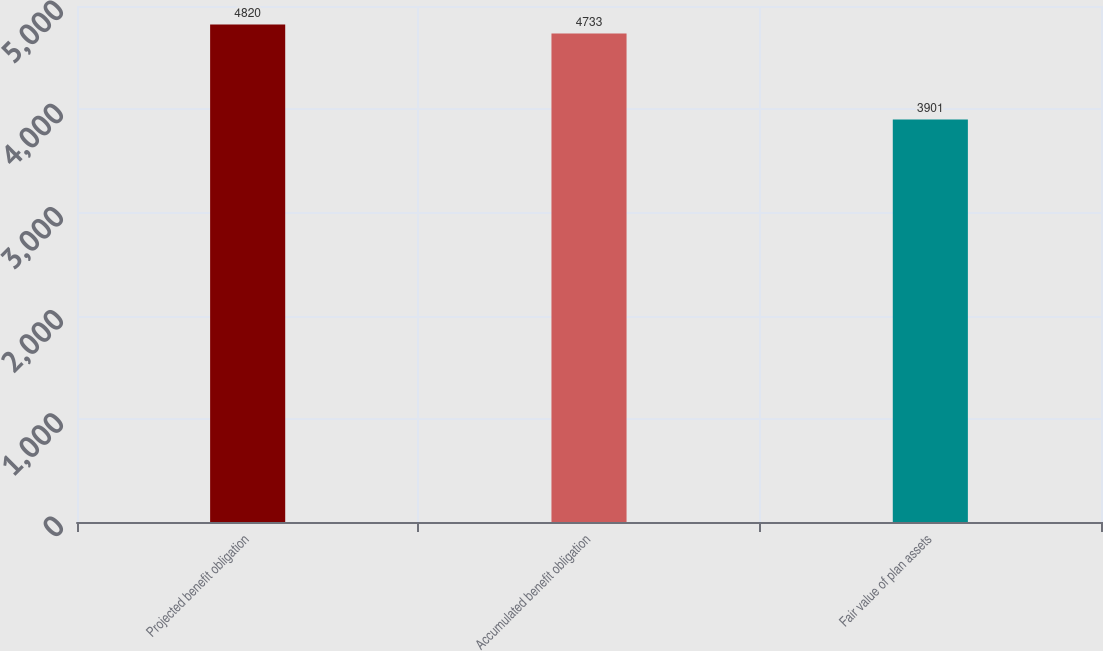Convert chart. <chart><loc_0><loc_0><loc_500><loc_500><bar_chart><fcel>Projected benefit obligation<fcel>Accumulated benefit obligation<fcel>Fair value of plan assets<nl><fcel>4820<fcel>4733<fcel>3901<nl></chart> 